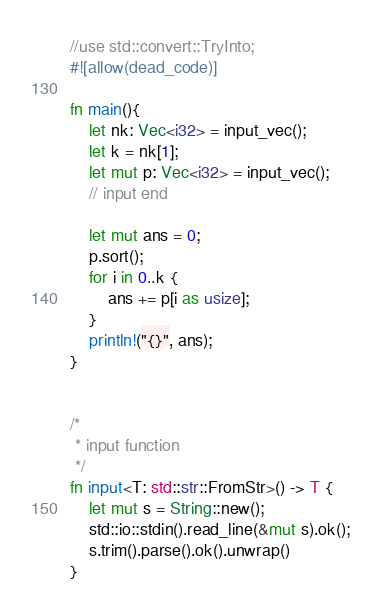Convert code to text. <code><loc_0><loc_0><loc_500><loc_500><_Rust_>//use std::convert::TryInto;
#![allow(dead_code)]

fn main(){
    let nk: Vec<i32> = input_vec();
    let k = nk[1];
    let mut p: Vec<i32> = input_vec();
    // input end

    let mut ans = 0;
    p.sort();
    for i in 0..k {
        ans += p[i as usize];
    }
    println!("{}", ans);
}


/*
 * input function
 */
fn input<T: std::str::FromStr>() -> T {
    let mut s = String::new();
    std::io::stdin().read_line(&mut s).ok();
    s.trim().parse().ok().unwrap()
}
</code> 